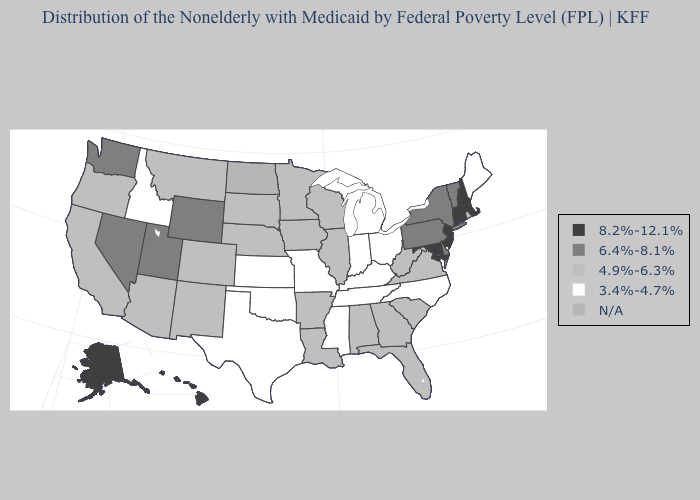What is the value of Oregon?
Short answer required. 4.9%-6.3%. Name the states that have a value in the range 8.2%-12.1%?
Quick response, please. Alaska, Connecticut, Hawaii, Maryland, Massachusetts, New Hampshire, New Jersey. Name the states that have a value in the range 3.4%-4.7%?
Concise answer only. Idaho, Indiana, Kansas, Kentucky, Maine, Michigan, Mississippi, Missouri, North Carolina, Ohio, Oklahoma, Tennessee, Texas. Does Massachusetts have the lowest value in the Northeast?
Short answer required. No. Name the states that have a value in the range 6.4%-8.1%?
Short answer required. Delaware, Nevada, New York, Pennsylvania, Utah, Vermont, Washington, Wyoming. What is the highest value in the USA?
Give a very brief answer. 8.2%-12.1%. What is the highest value in the Northeast ?
Keep it brief. 8.2%-12.1%. How many symbols are there in the legend?
Concise answer only. 5. Name the states that have a value in the range 8.2%-12.1%?
Quick response, please. Alaska, Connecticut, Hawaii, Maryland, Massachusetts, New Hampshire, New Jersey. What is the value of Indiana?
Answer briefly. 3.4%-4.7%. What is the highest value in the MidWest ?
Keep it brief. 4.9%-6.3%. Among the states that border Kentucky , does Illinois have the lowest value?
Quick response, please. No. Is the legend a continuous bar?
Write a very short answer. No. What is the value of South Carolina?
Be succinct. 4.9%-6.3%. 